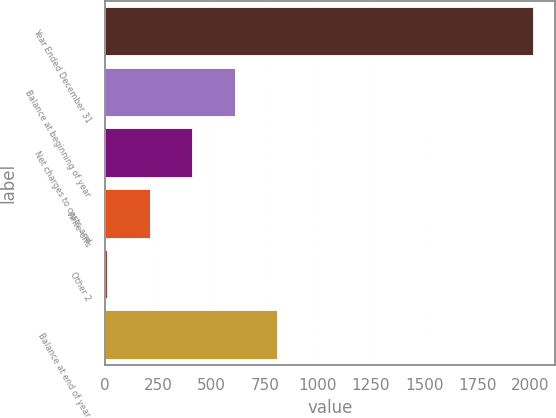<chart> <loc_0><loc_0><loc_500><loc_500><bar_chart><fcel>Year Ended December 31<fcel>Balance at beginning of year<fcel>Net charges to costs and<fcel>Write-offs<fcel>Other 2<fcel>Balance at end of year<nl><fcel>2013<fcel>609.5<fcel>409<fcel>208.5<fcel>8<fcel>810<nl></chart> 